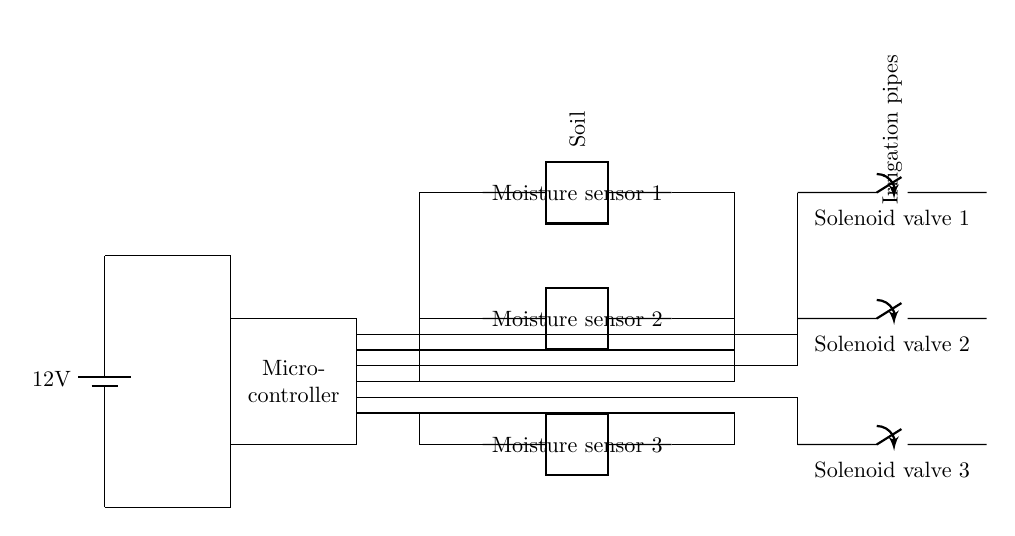What is the voltage of the power supply? The voltage shown for the power supply component is labeled as 12 volts, indicating that this is the potential difference supplied to the circuit.
Answer: 12 volts What components are connected to the microcontroller? The microcontroller is connected to three moisture sensors and to the three solenoid valves. These components form the control and output parts of the automated irrigation system, detailing the distinct inputs and outputs linked to the microcontroller.
Answer: Three moisture sensors and three solenoid valves How many moisture sensors are there in the circuit? The diagram clearly shows three moisture sensors drawn in the two-port configuration; they are labeled one, two, and three. These sensors are responsible for detecting soil moisture levels.
Answer: Three What do the solenoid valves control in this circuit? The solenoid valves are placed in line with the irrigation pipes, indicating that they govern the flow of water to the plants based on readings from the moisture sensors. The circuit is designed to enable or disable irrigation as needed.
Answer: Water flow If the moisture level is low, what will the microcontroller do? The microcontroller will receive a signal from the moisture sensors indicating low moisture levels. In response, it will activate the solenoid valves to open, allowing water to flow to the plants. This is a feedback loop that automates irrigation based on soil conditions.
Answer: Open solenoid valves Which components can be found downstream of the moisture sensors? Downstream of the moisture sensors are the solenoid valves, which are crucial for controlling the flow of irrigation water as dictated by the moisture levels detected. The layout of the circuit suggests a direct relationship between the sensors' readings and the valves' operation.
Answer: Solenoid valves 